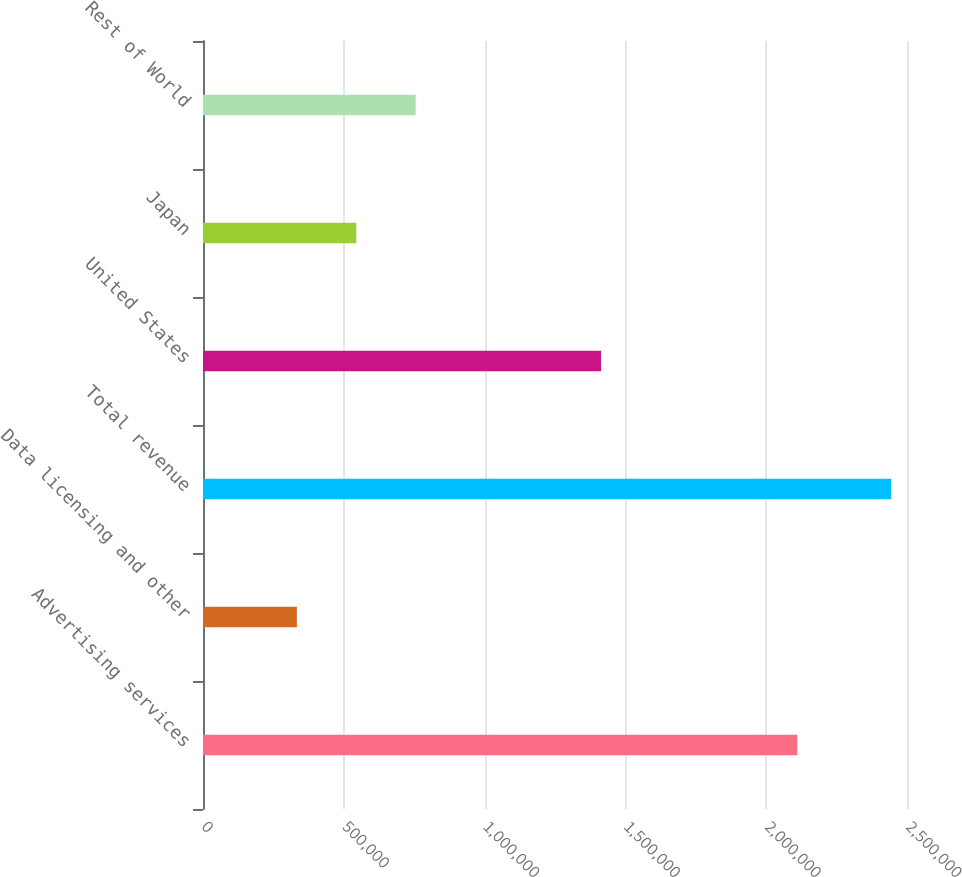<chart> <loc_0><loc_0><loc_500><loc_500><bar_chart><fcel>Advertising services<fcel>Data licensing and other<fcel>Total revenue<fcel>United States<fcel>Japan<fcel>Rest of World<nl><fcel>2.10999e+06<fcel>333312<fcel>2.4433e+06<fcel>1.41361e+06<fcel>544311<fcel>755309<nl></chart> 